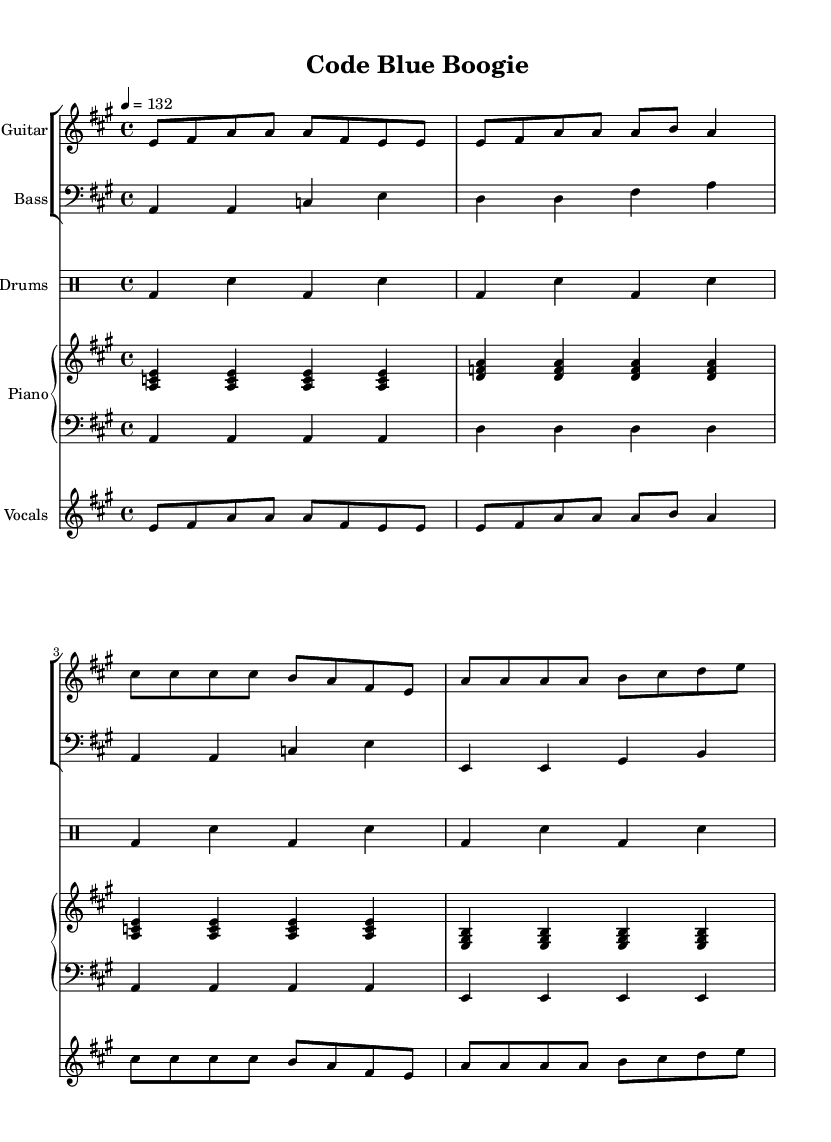What is the key signature of this music? The key signature is A major, which has three sharps (F#, C#, and G#). This is determined by examining the key signature indicated at the beginning of the sheet music.
Answer: A major What is the time signature of this music? The time signature is four-four, indicated by the "4/4" notation at the beginning of the sheet music. This means there are four beats in each measure and a quarter note gets one beat.
Answer: 4/4 What is the tempo marking for this piece? The tempo marking is 132 beats per minute, shown by the "4 = 132" notation in the score. This indicates how fast the music should be played.
Answer: 132 How many measures are in the song's electric guitar part? The electric guitar part consists of sixteen measures, as counted from the beginning to the end of the provided notes. Each line of music typically contains four measures, and there are four lines in total.
Answer: 16 What two main themes are presented in the lyrics of this song? The lyrics focus on themes of education and safety, which are apparent from the repeated phrases that emphasize the importance of sharing knowledge and staying safe. Specifically, the words encourage listeners to educate themselves and be proactive about health and safety.
Answer: Education and safety Is this song primarily in a major or minor tonality? This song is in a major tonality, as indicated by the key signature and the overall upbeat nature of the music. Blues music typically exhibits a feeling of joy or celebration that aligns with major keys.
Answer: Major What genre does this song belong to? This song belongs to the blues-rock genre, evidenced by the energetic blend of blues emotion with rock rhythms and instruments throughout the arrangement. This fusion of styles is characteristic of blues-rock music, highlighting both elements clearly.
Answer: Blues-rock 